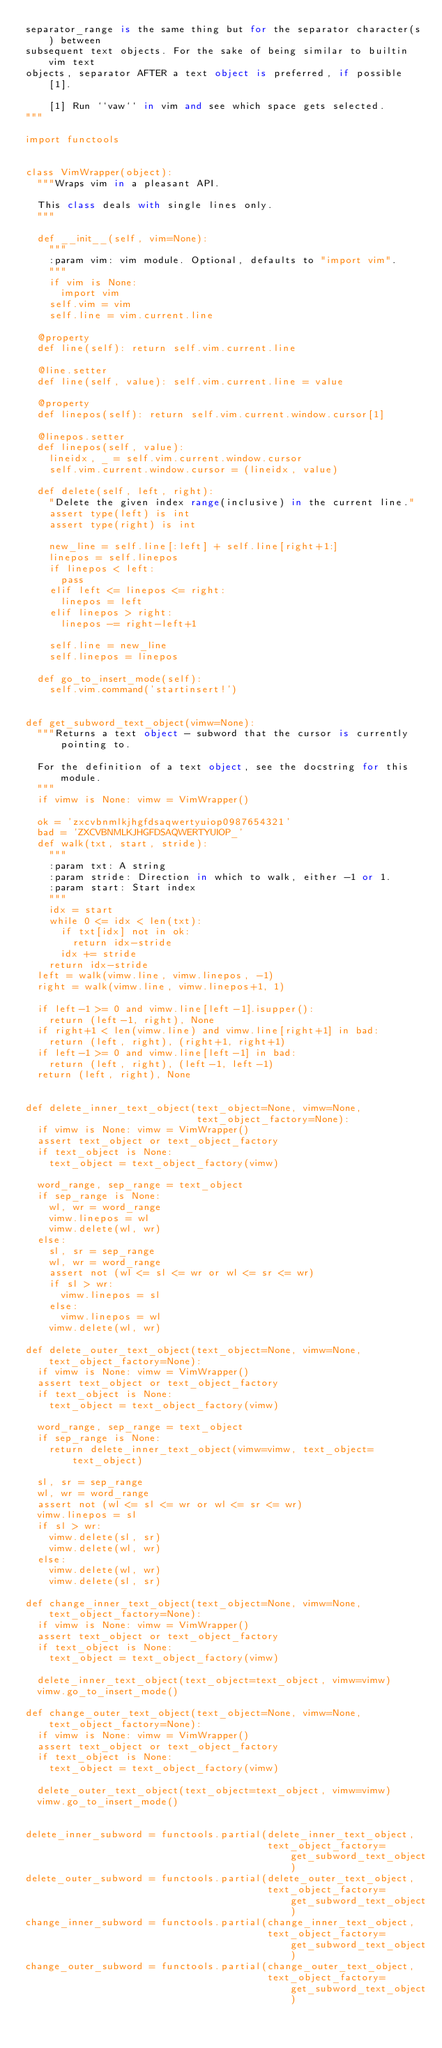Convert code to text. <code><loc_0><loc_0><loc_500><loc_500><_Python_>separator_range is the same thing but for the separator character(s) between
subsequent text objects. For the sake of being similar to builtin vim text
objects, separator AFTER a text object is preferred, if possible [1].

    [1] Run ``vaw`` in vim and see which space gets selected.
"""

import functools


class VimWrapper(object):
  """Wraps vim in a pleasant API.

  This class deals with single lines only.
  """

  def __init__(self, vim=None):
    """
    :param vim: vim module. Optional, defaults to "import vim".
    """
    if vim is None:
      import vim
    self.vim = vim
    self.line = vim.current.line

  @property
  def line(self): return self.vim.current.line

  @line.setter
  def line(self, value): self.vim.current.line = value

  @property
  def linepos(self): return self.vim.current.window.cursor[1]

  @linepos.setter
  def linepos(self, value):
    lineidx, _ = self.vim.current.window.cursor
    self.vim.current.window.cursor = (lineidx, value)

  def delete(self, left, right):
    "Delete the given index range(inclusive) in the current line."
    assert type(left) is int
    assert type(right) is int

    new_line = self.line[:left] + self.line[right+1:]
    linepos = self.linepos
    if linepos < left:
      pass
    elif left <= linepos <= right:
      linepos = left
    elif linepos > right:
      linepos -= right-left+1

    self.line = new_line
    self.linepos = linepos

  def go_to_insert_mode(self):
    self.vim.command('startinsert!')


def get_subword_text_object(vimw=None):
  """Returns a text object - subword that the cursor is currently pointing to.

  For the definition of a text object, see the docstring for this module.
  """
  if vimw is None: vimw = VimWrapper()

  ok = 'zxcvbnmlkjhgfdsaqwertyuiop0987654321'
  bad = 'ZXCVBNMLKJHGFDSAQWERTYUIOP_'
  def walk(txt, start, stride):
    """
    :param txt: A string
    :param stride: Direction in which to walk, either -1 or 1.
    :param start: Start index
    """
    idx = start
    while 0 <= idx < len(txt):
      if txt[idx] not in ok:
        return idx-stride
      idx += stride
    return idx-stride
  left = walk(vimw.line, vimw.linepos, -1)
  right = walk(vimw.line, vimw.linepos+1, 1)

  if left-1 >= 0 and vimw.line[left-1].isupper():
    return (left-1, right), None
  if right+1 < len(vimw.line) and vimw.line[right+1] in bad:
    return (left, right), (right+1, right+1)
  if left-1 >= 0 and vimw.line[left-1] in bad:
    return (left, right), (left-1, left-1)
  return (left, right), None


def delete_inner_text_object(text_object=None, vimw=None,
                             text_object_factory=None):
  if vimw is None: vimw = VimWrapper()
  assert text_object or text_object_factory
  if text_object is None:
    text_object = text_object_factory(vimw)

  word_range, sep_range = text_object
  if sep_range is None:
    wl, wr = word_range
    vimw.linepos = wl
    vimw.delete(wl, wr)
  else:
    sl, sr = sep_range
    wl, wr = word_range
    assert not (wl <= sl <= wr or wl <= sr <= wr)
    if sl > wr:
      vimw.linepos = sl
    else:
      vimw.linepos = wl
    vimw.delete(wl, wr)

def delete_outer_text_object(text_object=None, vimw=None, text_object_factory=None):
  if vimw is None: vimw = VimWrapper()
  assert text_object or text_object_factory
  if text_object is None:
    text_object = text_object_factory(vimw)

  word_range, sep_range = text_object
  if sep_range is None:
    return delete_inner_text_object(vimw=vimw, text_object=text_object)

  sl, sr = sep_range
  wl, wr = word_range
  assert not (wl <= sl <= wr or wl <= sr <= wr)
  vimw.linepos = sl
  if sl > wr:
    vimw.delete(sl, sr)
    vimw.delete(wl, wr)
  else:
    vimw.delete(wl, wr)
    vimw.delete(sl, sr)

def change_inner_text_object(text_object=None, vimw=None, text_object_factory=None):
  if vimw is None: vimw = VimWrapper()
  assert text_object or text_object_factory
  if text_object is None:
    text_object = text_object_factory(vimw)

  delete_inner_text_object(text_object=text_object, vimw=vimw)
  vimw.go_to_insert_mode()

def change_outer_text_object(text_object=None, vimw=None, text_object_factory=None):
  if vimw is None: vimw = VimWrapper()
  assert text_object or text_object_factory
  if text_object is None:
    text_object = text_object_factory(vimw)

  delete_outer_text_object(text_object=text_object, vimw=vimw)
  vimw.go_to_insert_mode()


delete_inner_subword = functools.partial(delete_inner_text_object,
                                         text_object_factory=get_subword_text_object)
delete_outer_subword = functools.partial(delete_outer_text_object,
                                         text_object_factory=get_subword_text_object)
change_inner_subword = functools.partial(change_inner_text_object,
                                         text_object_factory=get_subword_text_object)
change_outer_subword = functools.partial(change_outer_text_object,
                                         text_object_factory=get_subword_text_object)


</code> 